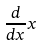<formula> <loc_0><loc_0><loc_500><loc_500>\frac { d } { d x } x</formula> 